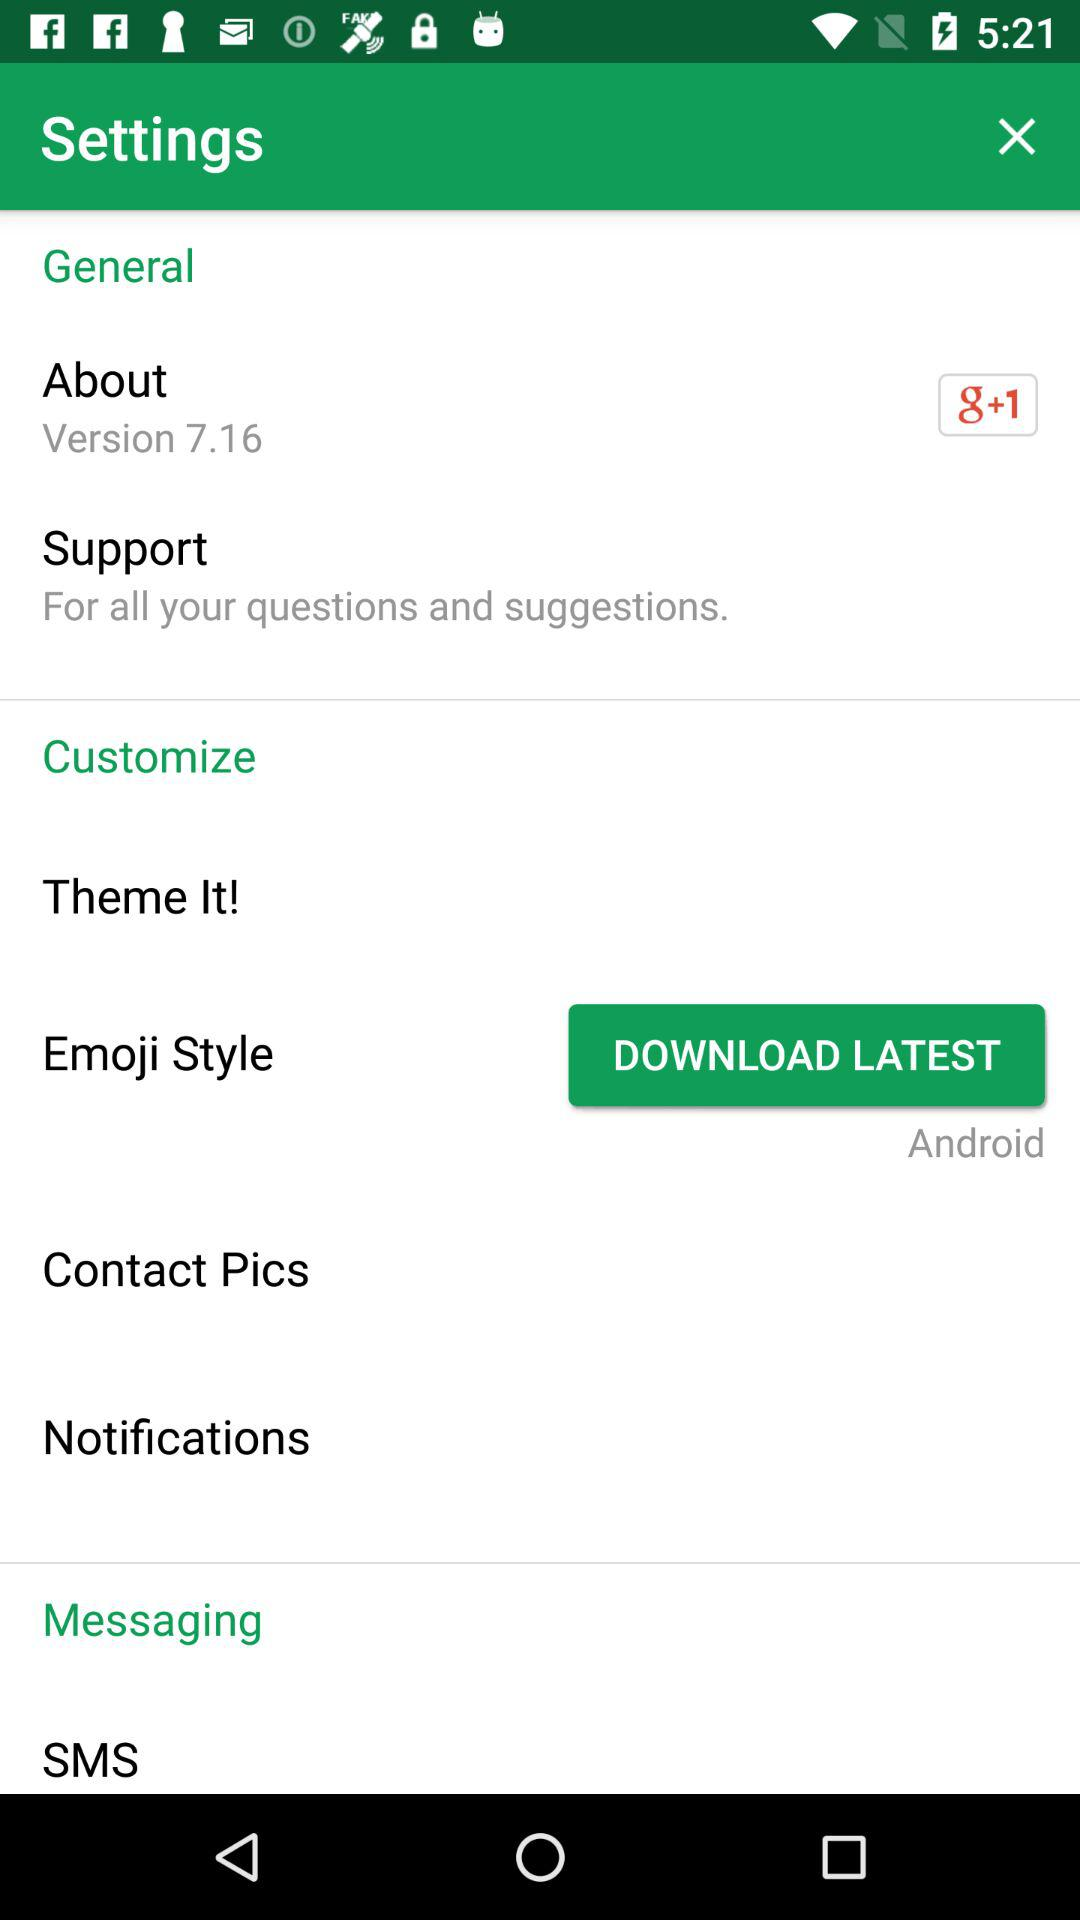What is the given version? The given version is 7.16. 